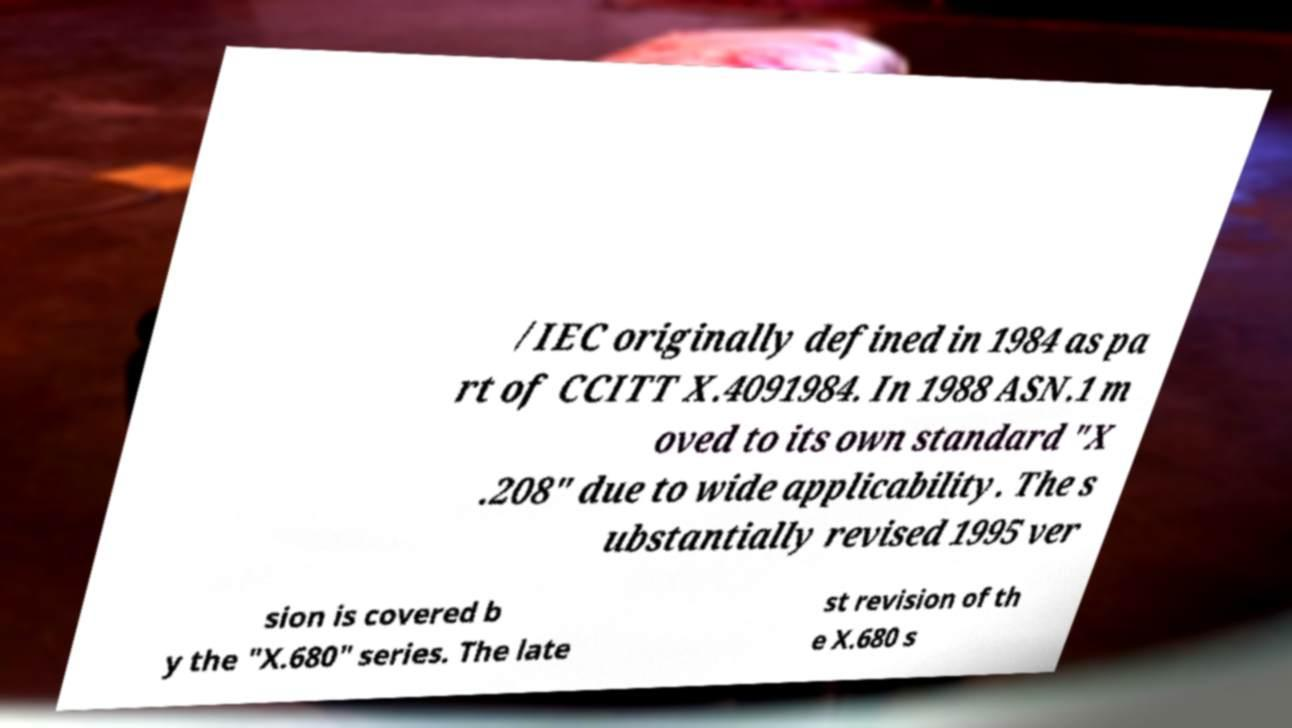Please read and relay the text visible in this image. What does it say? /IEC originally defined in 1984 as pa rt of CCITT X.4091984. In 1988 ASN.1 m oved to its own standard "X .208" due to wide applicability. The s ubstantially revised 1995 ver sion is covered b y the "X.680" series. The late st revision of th e X.680 s 